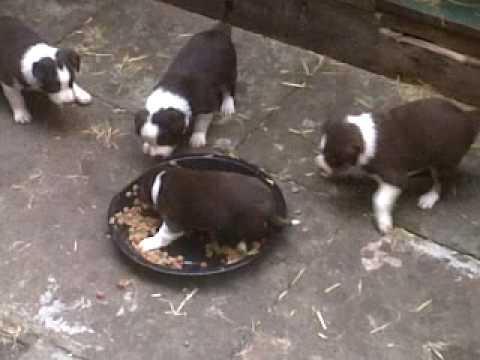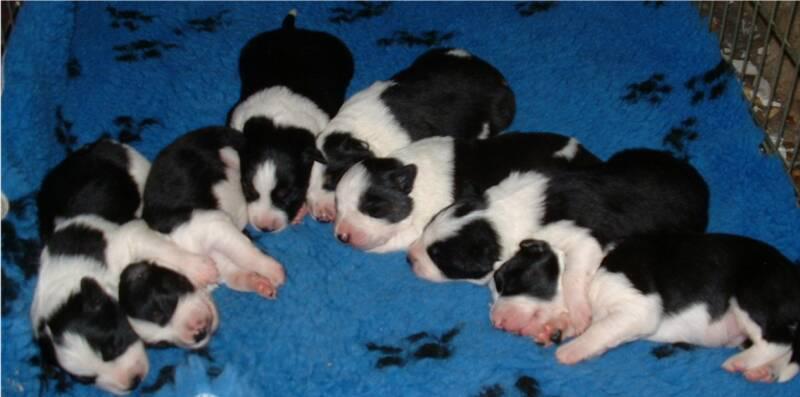The first image is the image on the left, the second image is the image on the right. For the images displayed, is the sentence "There is at least one human petting puppies in one of the images." factually correct? Answer yes or no. No. The first image is the image on the left, the second image is the image on the right. Given the left and right images, does the statement "An image contains exactly four puppies, all black and white and most of them reclining in a row." hold true? Answer yes or no. No. 